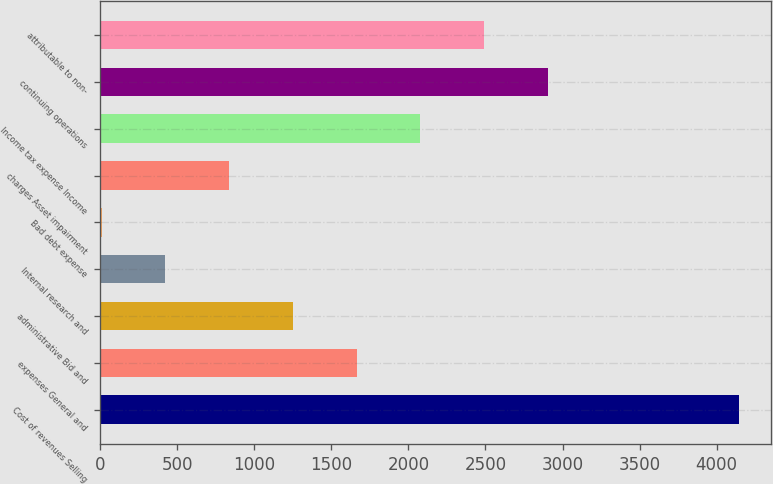Convert chart. <chart><loc_0><loc_0><loc_500><loc_500><bar_chart><fcel>Cost of revenues Selling<fcel>expenses General and<fcel>administrative Bid and<fcel>Internal research and<fcel>Bad debt expense<fcel>charges Asset impairment<fcel>Income tax expense Income<fcel>continuing operations<fcel>attributable to non-<nl><fcel>4146<fcel>1663.2<fcel>1249.4<fcel>421.8<fcel>8<fcel>835.6<fcel>2077<fcel>2904.6<fcel>2490.8<nl></chart> 